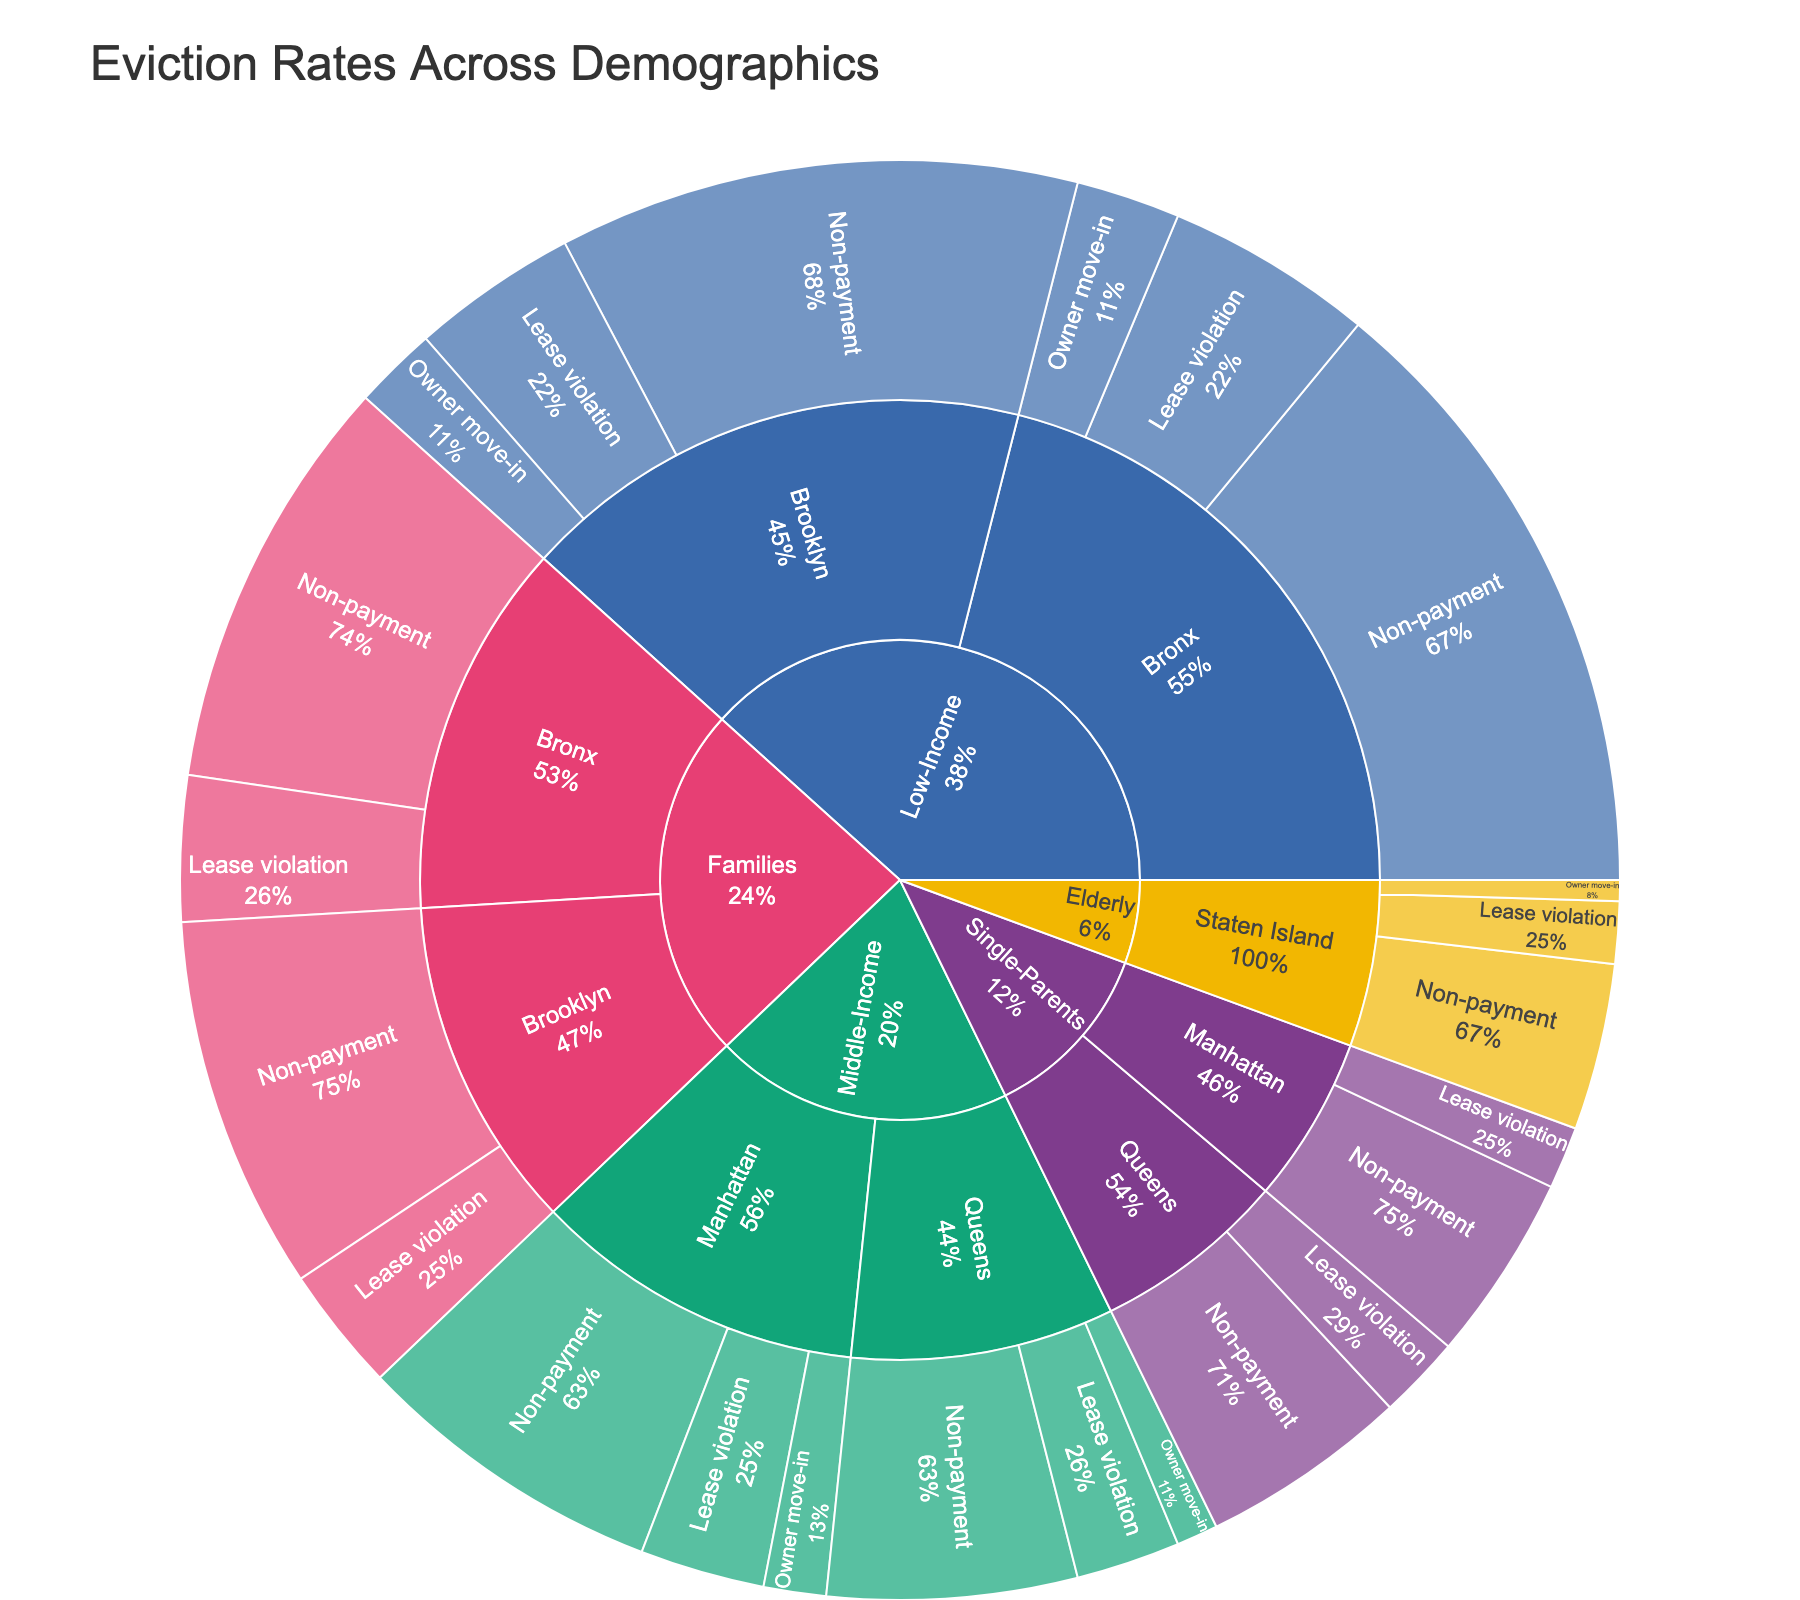What is the title of the plot? The title is displayed at the top of the figure. It helps in quickly understanding the subject of the visualization.
Answer: Eviction Rates Across Demographics Which category has the highest percentage of evictions due to non-payment in the Bronx? Look at the Sunburst Plot and find the section corresponding to the Bronx under the Low-Income category, then check the percentages for the reasons.
Answer: Low-Income What percentage of evictions for families in Brooklyn are due to lease violations? Identify the section for Families under Brooklyn and note the percentage for lease violations.
Answer: 6% Compare the eviction rates due to non-payment between Low-Income residents in Brooklyn and Middle-Income residents in Queens. Which is higher? Locate the sections for Low-Income and Middle-Income categories under their respective neighborhoods and compare the non-payment percentages.
Answer: Low-Income in Brooklyn What is the combined percentage of evictions due to owner move-in across all neighborhoods and demographics? Sum the percentages for owner move-in across all categories and neighborhoods. Low-Income in Bronx (5), Low-Income in Brooklyn (4), Middle-Income in Manhattan (3), Middle-Income in Queens (2), Elderly in Staten Island (1) = 15
Answer: 15% Among the single-parents in Queens and Manhattan, who faces a higher eviction rate due to lease violations? Locate Single-Parents category in Queens and Manhattan and compare the lease violation percentages.
Answer: Queens What is the percentage of evictions for middle-income residents in Manhattan due to reasons other than non-payment? Sum the percentages of evictions due to lease violations and owner move-in for middle-income residents in Manhattan (6% for lease violation, 3% for owner move-in).
Answer: 9% Which neighborhood has the highest eviction rate for elderly residents due to non-payment? Locate the Elderly category and look at the non-payment percentages for the neighborhoods.
Answer: Staten Island Compare the total eviction percentages for Low-Income residents in Bronx and Brooklyn. Which neighborhood has a higher total eviction percentage? Sum the percentages of all reasons (non-payment, lease violation, owner move-in) for Low-Income residents in both Bronx and Brooklyn. Bronx total: 30+10+5=45, Brooklyn total: 25+8+4=37.
Answer: Bronx How does the percentage of evictions due to lease violations for families in the Bronx compare to those for single-parents in Queens? Compare the lease violation percentages for Families in the Bronx and Single-Parents in Queens.
Answer: Families in the Bronx are higher 